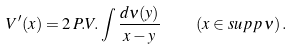<formula> <loc_0><loc_0><loc_500><loc_500>V ^ { \prime } ( x ) = 2 \, P . V . \int \frac { d \nu ( y ) } { x - y } \quad ( x \in s u p p \, \nu ) \, .</formula> 